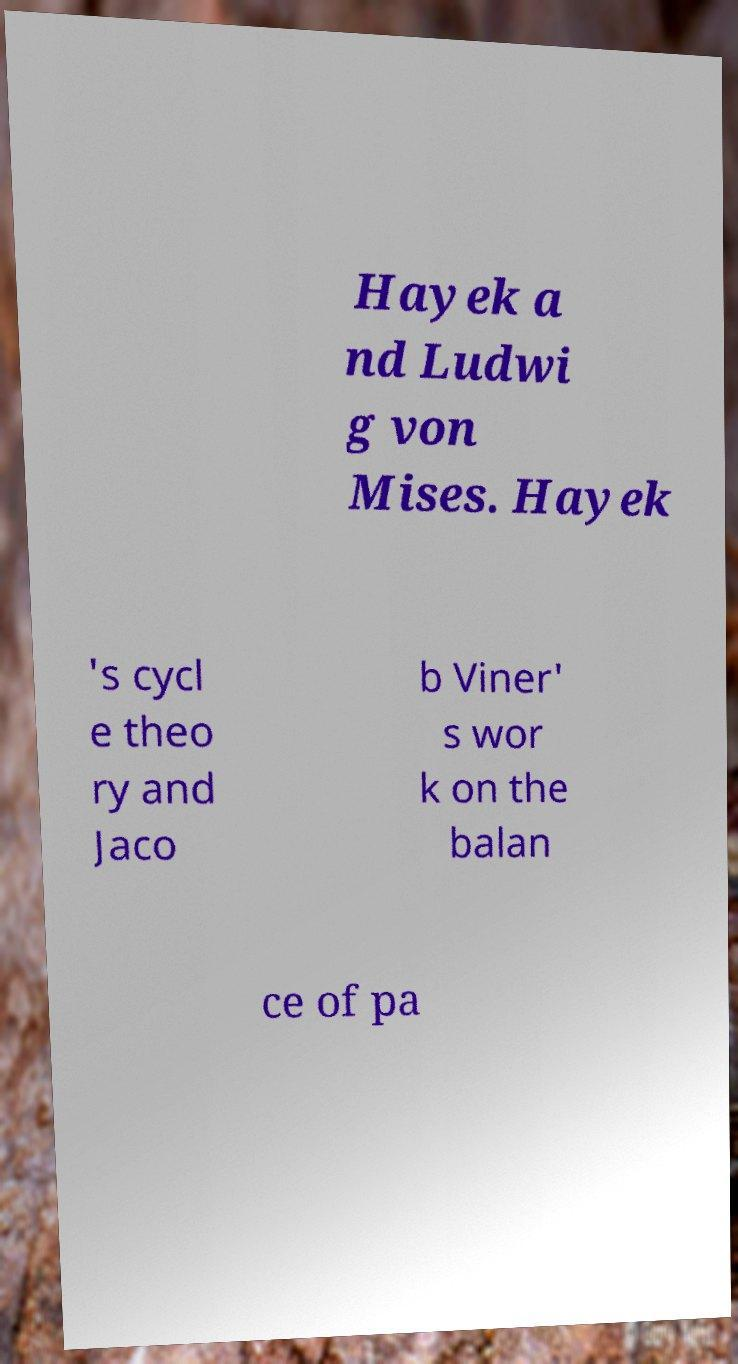There's text embedded in this image that I need extracted. Can you transcribe it verbatim? Hayek a nd Ludwi g von Mises. Hayek 's cycl e theo ry and Jaco b Viner' s wor k on the balan ce of pa 